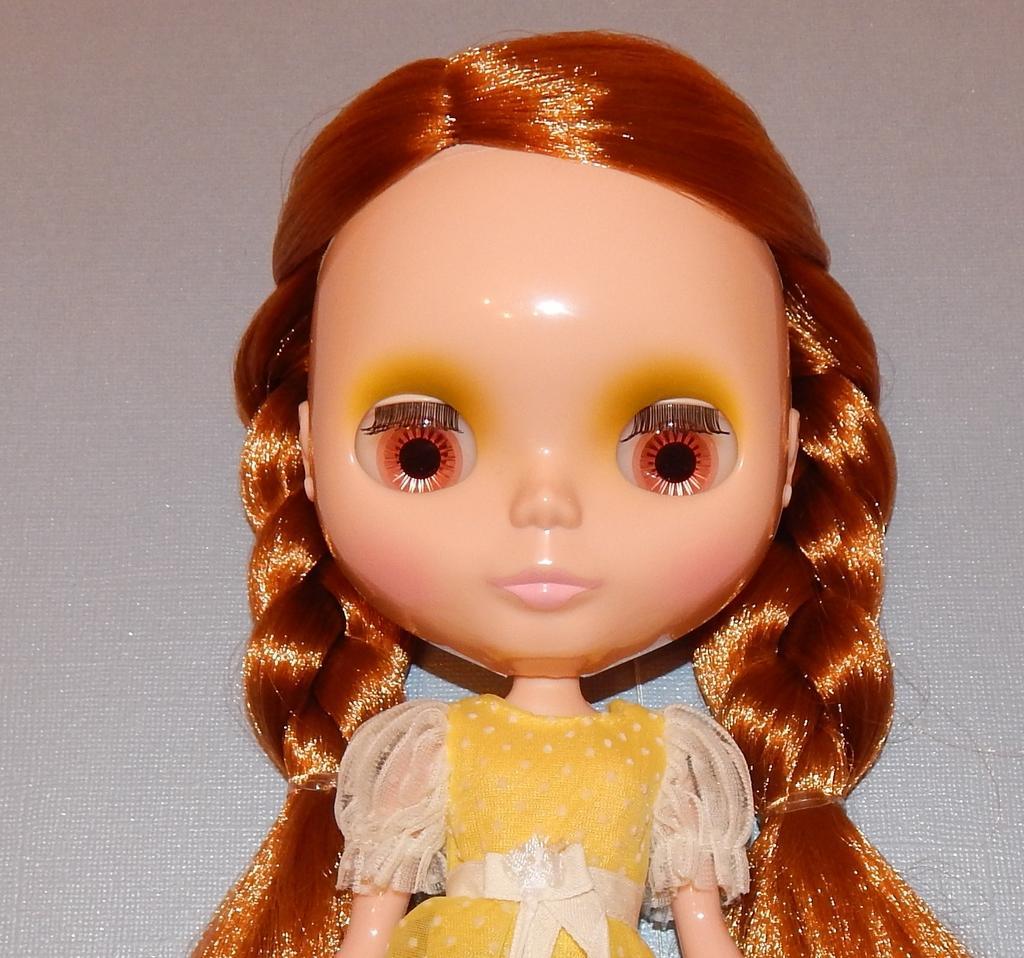Describe this image in one or two sentences. In this image we can see a doll placed on the surface. 